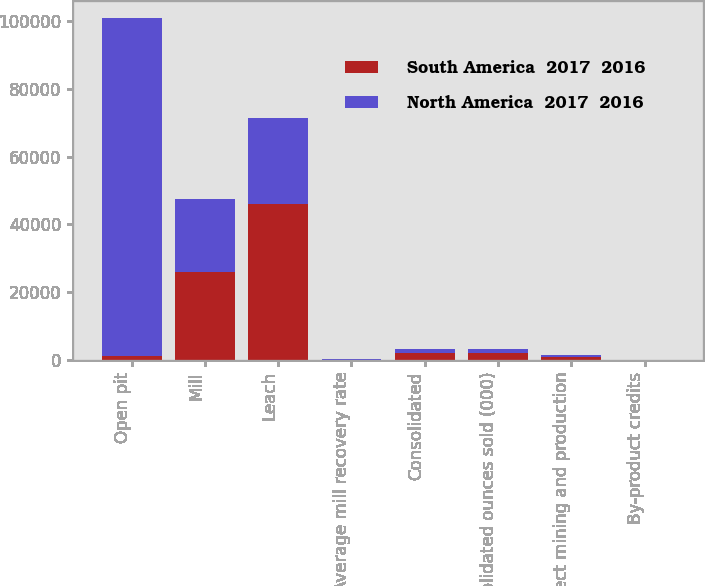Convert chart. <chart><loc_0><loc_0><loc_500><loc_500><stacked_bar_chart><ecel><fcel>Open pit<fcel>Mill<fcel>Leach<fcel>Average mill recovery rate<fcel>Consolidated<fcel>Consolidated ounces sold (000)<fcel>Direct mining and production<fcel>By-product credits<nl><fcel>South America  2017  2016<fcel>1060<fcel>25879<fcel>46034<fcel>76.7<fcel>2057<fcel>2052<fcel>753<fcel>8<nl><fcel>North America  2017  2016<fcel>99793<fcel>21666<fcel>25405<fcel>88<fcel>1049<fcel>1060<fcel>593<fcel>19<nl></chart> 